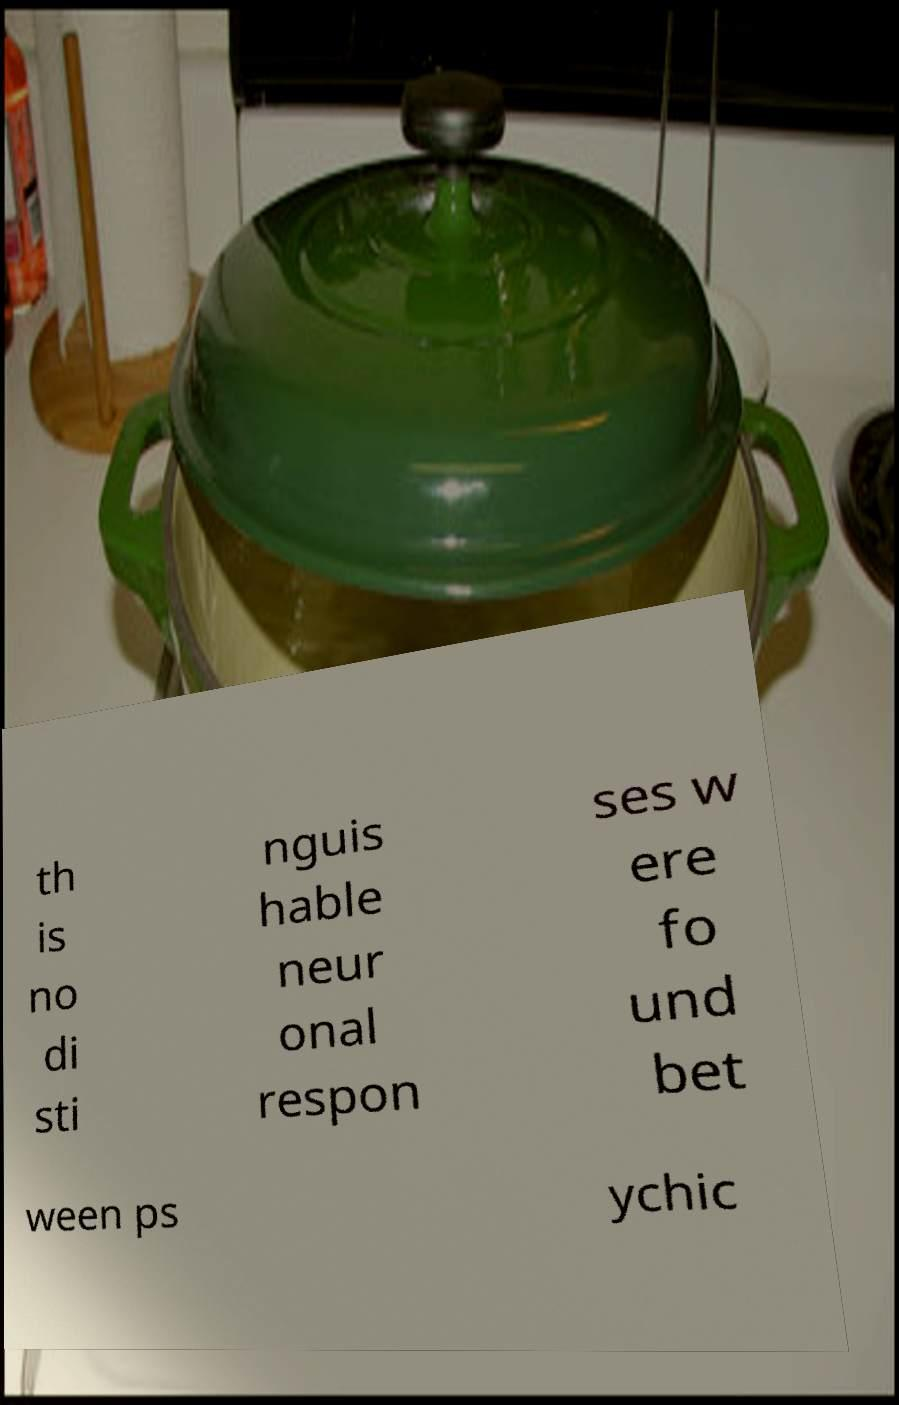Please read and relay the text visible in this image. What does it say? th is no di sti nguis hable neur onal respon ses w ere fo und bet ween ps ychic 